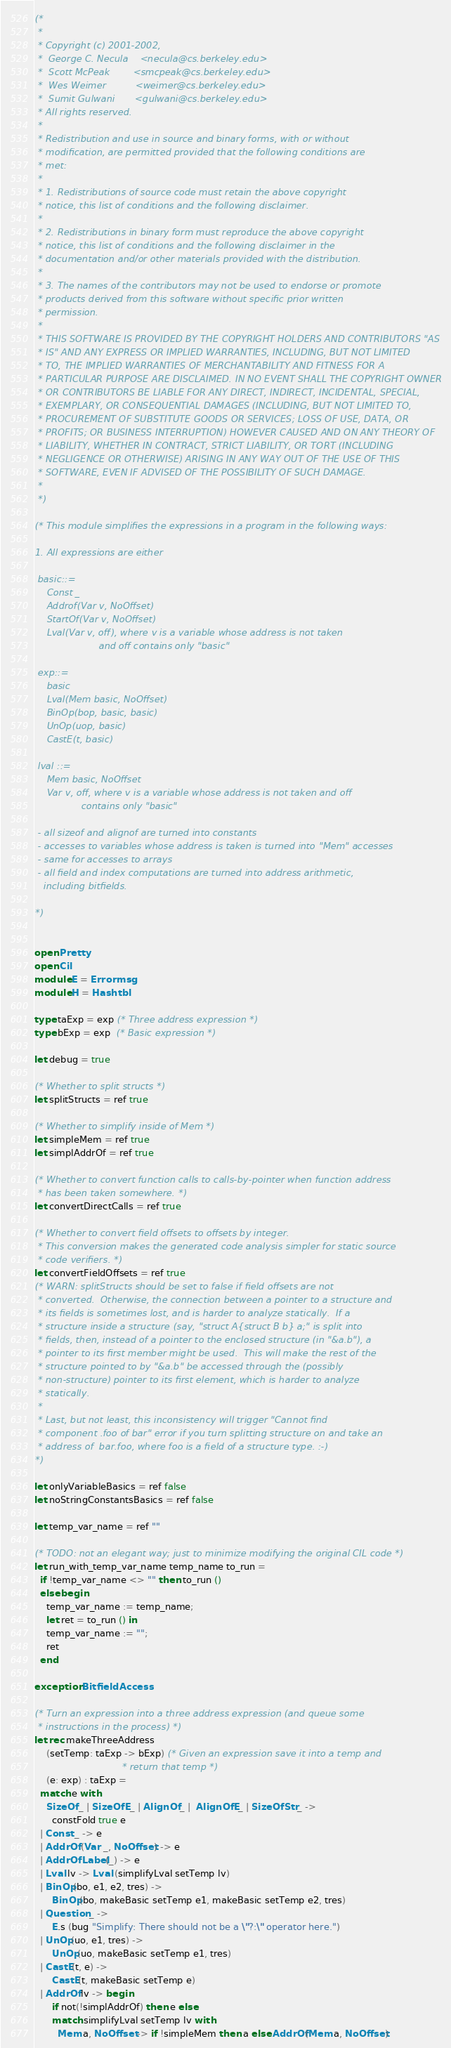<code> <loc_0><loc_0><loc_500><loc_500><_OCaml_>(*
 *
 * Copyright (c) 2001-2002, 
 *  George C. Necula    <necula@cs.berkeley.edu>
 *  Scott McPeak        <smcpeak@cs.berkeley.edu>
 *  Wes Weimer          <weimer@cs.berkeley.edu>
 *  Sumit Gulwani       <gulwani@cs.berkeley.edu>
 * All rights reserved.
 * 
 * Redistribution and use in source and binary forms, with or without
 * modification, are permitted provided that the following conditions are
 * met:
 *
 * 1. Redistributions of source code must retain the above copyright
 * notice, this list of conditions and the following disclaimer.
 *
 * 2. Redistributions in binary form must reproduce the above copyright
 * notice, this list of conditions and the following disclaimer in the
 * documentation and/or other materials provided with the distribution.
 *
 * 3. The names of the contributors may not be used to endorse or promote
 * products derived from this software without specific prior written
 * permission.
 *
 * THIS SOFTWARE IS PROVIDED BY THE COPYRIGHT HOLDERS AND CONTRIBUTORS "AS
 * IS" AND ANY EXPRESS OR IMPLIED WARRANTIES, INCLUDING, BUT NOT LIMITED
 * TO, THE IMPLIED WARRANTIES OF MERCHANTABILITY AND FITNESS FOR A
 * PARTICULAR PURPOSE ARE DISCLAIMED. IN NO EVENT SHALL THE COPYRIGHT OWNER
 * OR CONTRIBUTORS BE LIABLE FOR ANY DIRECT, INDIRECT, INCIDENTAL, SPECIAL,
 * EXEMPLARY, OR CONSEQUENTIAL DAMAGES (INCLUDING, BUT NOT LIMITED TO,
 * PROCUREMENT OF SUBSTITUTE GOODS OR SERVICES; LOSS OF USE, DATA, OR
 * PROFITS; OR BUSINESS INTERRUPTION) HOWEVER CAUSED AND ON ANY THEORY OF
 * LIABILITY, WHETHER IN CONTRACT, STRICT LIABILITY, OR TORT (INCLUDING
 * NEGLIGENCE OR OTHERWISE) ARISING IN ANY WAY OUT OF THE USE OF THIS
 * SOFTWARE, EVEN IF ADVISED OF THE POSSIBILITY OF SUCH DAMAGE.
 *
 *)

(* This module simplifies the expressions in a program in the following ways:
 
1. All expressions are either 

 basic::=
    Const _ 
    Addrof(Var v, NoOffset)
    StartOf(Var v, NoOffset)
    Lval(Var v, off), where v is a variable whose address is not taken
                      and off contains only "basic"

 exp::=
    basic
    Lval(Mem basic, NoOffset)
    BinOp(bop, basic, basic)
    UnOp(uop, basic)
    CastE(t, basic)
   
 lval ::= 
    Mem basic, NoOffset
    Var v, off, where v is a variable whose address is not taken and off
                contains only "basic"

 - all sizeof and alignof are turned into constants
 - accesses to variables whose address is taken is turned into "Mem" accesses
 - same for accesses to arrays
 - all field and index computations are turned into address arithmetic, 
   including bitfields.

*)


open Pretty
open Cil
module E = Errormsg
module H = Hashtbl

type taExp = exp (* Three address expression *)
type bExp = exp  (* Basic expression *)

let debug = true

(* Whether to split structs *)
let splitStructs = ref true

(* Whether to simplify inside of Mem *)
let simpleMem = ref true
let simplAddrOf = ref true

(* Whether to convert function calls to calls-by-pointer when function address
 * has been taken somewhere. *)
let convertDirectCalls = ref true

(* Whether to convert field offsets to offsets by integer.
 * This conversion makes the generated code analysis simpler for static source
 * code verifiers. *)
let convertFieldOffsets = ref true
(* WARN: splitStructs should be set to false if field offsets are not
 * converted.  Otherwise, the connection between a pointer to a structure and
 * its fields is sometimes lost, and is harder to analyze statically.  If a
 * structure inside a structure (say, "struct A{struct B b} a;" is split into
 * fields, then, instead of a pointer to the enclosed structure (in "&a.b"), a
 * pointer to its first member might be used.  This will make the rest of the
 * structure pointed to by "&a.b" be accessed through the (possibly
 * non-structure) pointer to its first element, which is harder to analyze
 * statically.
 *
 * Last, but not least, this inconsistency will trigger "Cannot find
 * component .foo of bar" error if you turn splitting structure on and take an
 * address of  bar.foo, where foo is a field of a structure type. :-)
*)

let onlyVariableBasics = ref false
let noStringConstantsBasics = ref false

let temp_var_name = ref ""

(* TODO: not an elegant way; just to minimize modifying the original CIL code *)
let run_with_temp_var_name temp_name to_run =
  if !temp_var_name <> "" then to_run ()
  else begin
    temp_var_name := temp_name;
    let ret = to_run () in
    temp_var_name := "";
    ret
  end

exception BitfieldAccess

(* Turn an expression into a three address expression (and queue some 
 * instructions in the process) *)
let rec makeThreeAddress 
    (setTemp: taExp -> bExp) (* Given an expression save it into a temp and 
                              * return that temp *)
    (e: exp) : taExp = 
  match e with 
    SizeOf _ | SizeOfE _ | AlignOf _ |  AlignOfE _ | SizeOfStr _ -> 
      constFold true e
  | Const _ -> e
  | AddrOf (Var _, NoOffset) -> e
  | AddrOfLabel (_) -> e
  | Lval lv -> Lval (simplifyLval setTemp lv)
  | BinOp(bo, e1, e2, tres) -> 
      BinOp(bo, makeBasic setTemp e1, makeBasic setTemp e2, tres)
  | Question _ ->
      E.s (bug "Simplify: There should not be a \"?:\" operator here.")
  | UnOp(uo, e1, tres) -> 
      UnOp(uo, makeBasic setTemp e1, tres)
  | CastE(t, e) -> 
      CastE(t, makeBasic setTemp e)
  | AddrOf lv -> begin
      if not(!simplAddrOf) then e else
      match simplifyLval setTemp lv with 
        Mem a, NoOffset -> if !simpleMem then a else AddrOf(Mem a, NoOffset)</code> 